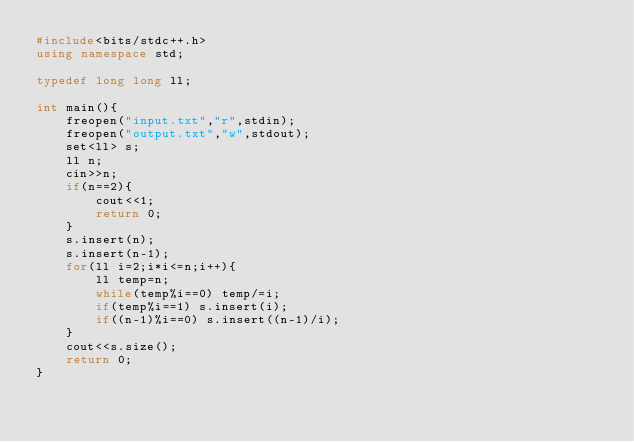Convert code to text. <code><loc_0><loc_0><loc_500><loc_500><_C++_>#include<bits/stdc++.h>
using namespace std;

typedef long long ll;

int main(){
	freopen("input.txt","r",stdin);
	freopen("output.txt","w",stdout);
	set<ll> s;
	ll n;
	cin>>n;
	if(n==2){
		cout<<1;
		return 0;
	}
	s.insert(n);
	s.insert(n-1);
	for(ll i=2;i*i<=n;i++){
		ll temp=n;
		while(temp%i==0) temp/=i;
		if(temp%i==1) s.insert(i);
		if((n-1)%i==0) s.insert((n-1)/i);
	}
	cout<<s.size();
	return 0;
}</code> 